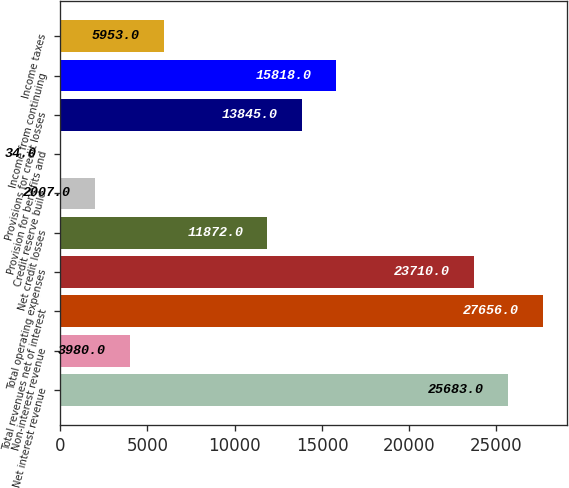Convert chart. <chart><loc_0><loc_0><loc_500><loc_500><bar_chart><fcel>Net interest revenue<fcel>Non-interest revenue<fcel>Total revenues net of interest<fcel>Total operating expenses<fcel>Net credit losses<fcel>Credit reserve build<fcel>Provision for benefits and<fcel>Provisions for credit losses<fcel>Income from continuing<fcel>Income taxes<nl><fcel>25683<fcel>3980<fcel>27656<fcel>23710<fcel>11872<fcel>2007<fcel>34<fcel>13845<fcel>15818<fcel>5953<nl></chart> 